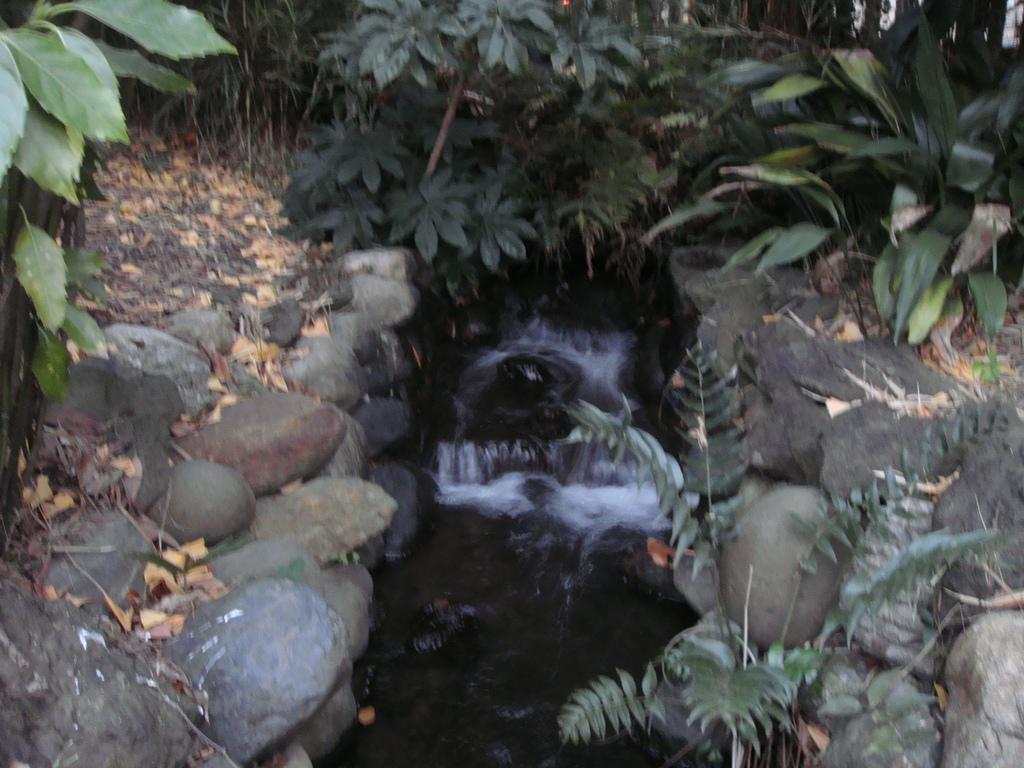Describe this image in one or two sentences. In this image I can see in the middle water is flowing, there are stones on either side of this image, at the back side there are trees. 